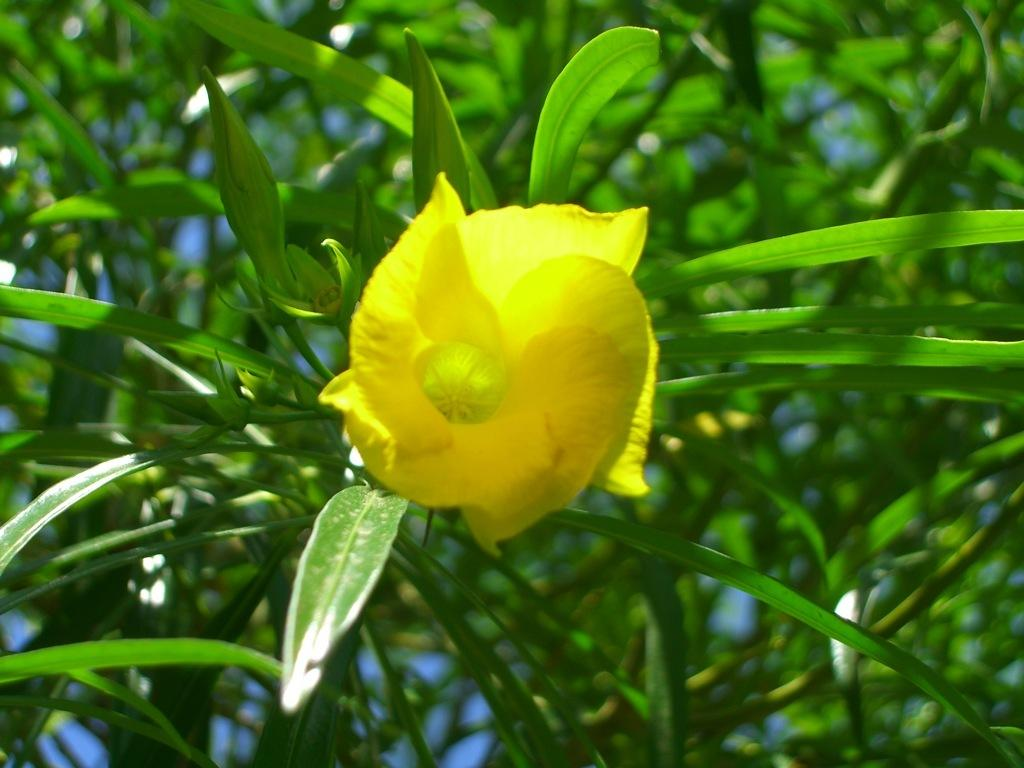What is the main subject of the image? There is a flower in the middle of the image. What can be seen in the background of the image? There are leaves in the background of the image. How does the boy feel about the jam in the image? There is no boy or jam present in the image, so this question cannot be answered. 